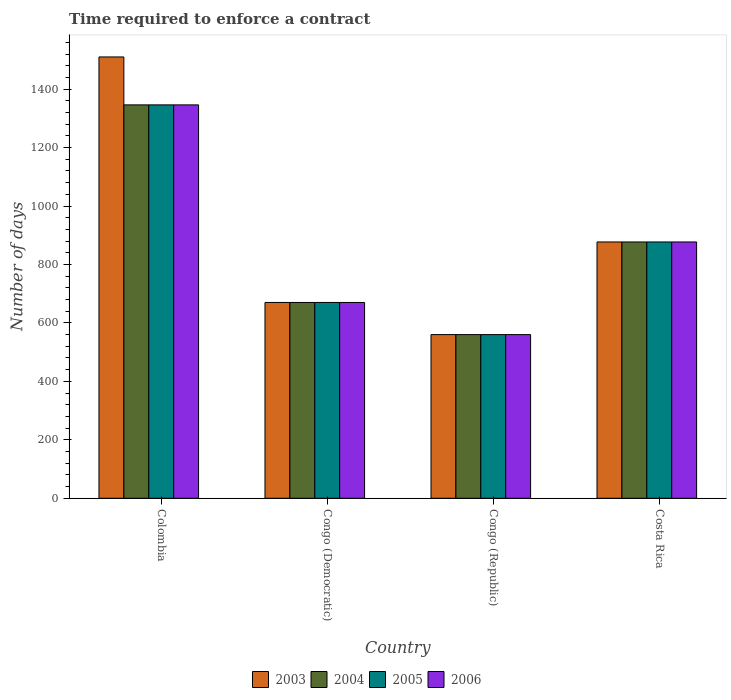How many different coloured bars are there?
Keep it short and to the point. 4. Are the number of bars per tick equal to the number of legend labels?
Your answer should be compact. Yes. How many bars are there on the 4th tick from the right?
Keep it short and to the point. 4. What is the label of the 2nd group of bars from the left?
Provide a short and direct response. Congo (Democratic). What is the number of days required to enforce a contract in 2006 in Congo (Republic)?
Provide a short and direct response. 560. Across all countries, what is the maximum number of days required to enforce a contract in 2003?
Provide a short and direct response. 1510. Across all countries, what is the minimum number of days required to enforce a contract in 2003?
Ensure brevity in your answer.  560. In which country was the number of days required to enforce a contract in 2003 minimum?
Keep it short and to the point. Congo (Republic). What is the total number of days required to enforce a contract in 2005 in the graph?
Give a very brief answer. 3453. What is the difference between the number of days required to enforce a contract in 2005 in Congo (Republic) and that in Costa Rica?
Give a very brief answer. -317. What is the difference between the number of days required to enforce a contract in 2003 in Congo (Democratic) and the number of days required to enforce a contract in 2005 in Congo (Republic)?
Ensure brevity in your answer.  110. What is the average number of days required to enforce a contract in 2005 per country?
Give a very brief answer. 863.25. What is the difference between the number of days required to enforce a contract of/in 2005 and number of days required to enforce a contract of/in 2004 in Congo (Democratic)?
Your answer should be compact. 0. In how many countries, is the number of days required to enforce a contract in 2006 greater than 1400 days?
Your answer should be compact. 0. What is the ratio of the number of days required to enforce a contract in 2006 in Colombia to that in Congo (Democratic)?
Offer a very short reply. 2.01. Is the number of days required to enforce a contract in 2006 in Congo (Democratic) less than that in Congo (Republic)?
Ensure brevity in your answer.  No. What is the difference between the highest and the second highest number of days required to enforce a contract in 2004?
Make the answer very short. 469. What is the difference between the highest and the lowest number of days required to enforce a contract in 2003?
Provide a succinct answer. 950. In how many countries, is the number of days required to enforce a contract in 2003 greater than the average number of days required to enforce a contract in 2003 taken over all countries?
Ensure brevity in your answer.  1. Is the sum of the number of days required to enforce a contract in 2003 in Congo (Republic) and Costa Rica greater than the maximum number of days required to enforce a contract in 2006 across all countries?
Offer a terse response. Yes. What does the 3rd bar from the right in Costa Rica represents?
Ensure brevity in your answer.  2004. Are all the bars in the graph horizontal?
Make the answer very short. No. What is the difference between two consecutive major ticks on the Y-axis?
Keep it short and to the point. 200. Does the graph contain grids?
Provide a short and direct response. No. Where does the legend appear in the graph?
Keep it short and to the point. Bottom center. How many legend labels are there?
Ensure brevity in your answer.  4. What is the title of the graph?
Your answer should be compact. Time required to enforce a contract. What is the label or title of the X-axis?
Make the answer very short. Country. What is the label or title of the Y-axis?
Offer a terse response. Number of days. What is the Number of days in 2003 in Colombia?
Provide a short and direct response. 1510. What is the Number of days of 2004 in Colombia?
Your answer should be very brief. 1346. What is the Number of days in 2005 in Colombia?
Make the answer very short. 1346. What is the Number of days in 2006 in Colombia?
Your answer should be very brief. 1346. What is the Number of days in 2003 in Congo (Democratic)?
Offer a terse response. 670. What is the Number of days in 2004 in Congo (Democratic)?
Ensure brevity in your answer.  670. What is the Number of days of 2005 in Congo (Democratic)?
Your answer should be very brief. 670. What is the Number of days of 2006 in Congo (Democratic)?
Offer a terse response. 670. What is the Number of days of 2003 in Congo (Republic)?
Provide a succinct answer. 560. What is the Number of days of 2004 in Congo (Republic)?
Provide a short and direct response. 560. What is the Number of days of 2005 in Congo (Republic)?
Offer a very short reply. 560. What is the Number of days of 2006 in Congo (Republic)?
Your response must be concise. 560. What is the Number of days of 2003 in Costa Rica?
Your answer should be compact. 877. What is the Number of days in 2004 in Costa Rica?
Offer a very short reply. 877. What is the Number of days of 2005 in Costa Rica?
Your answer should be compact. 877. What is the Number of days of 2006 in Costa Rica?
Your response must be concise. 877. Across all countries, what is the maximum Number of days of 2003?
Offer a very short reply. 1510. Across all countries, what is the maximum Number of days of 2004?
Offer a very short reply. 1346. Across all countries, what is the maximum Number of days of 2005?
Provide a short and direct response. 1346. Across all countries, what is the maximum Number of days in 2006?
Give a very brief answer. 1346. Across all countries, what is the minimum Number of days of 2003?
Ensure brevity in your answer.  560. Across all countries, what is the minimum Number of days in 2004?
Ensure brevity in your answer.  560. Across all countries, what is the minimum Number of days of 2005?
Offer a terse response. 560. Across all countries, what is the minimum Number of days in 2006?
Provide a short and direct response. 560. What is the total Number of days in 2003 in the graph?
Your answer should be very brief. 3617. What is the total Number of days of 2004 in the graph?
Give a very brief answer. 3453. What is the total Number of days of 2005 in the graph?
Ensure brevity in your answer.  3453. What is the total Number of days in 2006 in the graph?
Your response must be concise. 3453. What is the difference between the Number of days in 2003 in Colombia and that in Congo (Democratic)?
Provide a succinct answer. 840. What is the difference between the Number of days of 2004 in Colombia and that in Congo (Democratic)?
Offer a very short reply. 676. What is the difference between the Number of days in 2005 in Colombia and that in Congo (Democratic)?
Give a very brief answer. 676. What is the difference between the Number of days in 2006 in Colombia and that in Congo (Democratic)?
Provide a short and direct response. 676. What is the difference between the Number of days of 2003 in Colombia and that in Congo (Republic)?
Make the answer very short. 950. What is the difference between the Number of days in 2004 in Colombia and that in Congo (Republic)?
Ensure brevity in your answer.  786. What is the difference between the Number of days of 2005 in Colombia and that in Congo (Republic)?
Offer a terse response. 786. What is the difference between the Number of days in 2006 in Colombia and that in Congo (Republic)?
Keep it short and to the point. 786. What is the difference between the Number of days of 2003 in Colombia and that in Costa Rica?
Your response must be concise. 633. What is the difference between the Number of days in 2004 in Colombia and that in Costa Rica?
Ensure brevity in your answer.  469. What is the difference between the Number of days in 2005 in Colombia and that in Costa Rica?
Provide a succinct answer. 469. What is the difference between the Number of days of 2006 in Colombia and that in Costa Rica?
Keep it short and to the point. 469. What is the difference between the Number of days of 2003 in Congo (Democratic) and that in Congo (Republic)?
Offer a terse response. 110. What is the difference between the Number of days of 2004 in Congo (Democratic) and that in Congo (Republic)?
Make the answer very short. 110. What is the difference between the Number of days of 2005 in Congo (Democratic) and that in Congo (Republic)?
Your response must be concise. 110. What is the difference between the Number of days of 2006 in Congo (Democratic) and that in Congo (Republic)?
Offer a terse response. 110. What is the difference between the Number of days in 2003 in Congo (Democratic) and that in Costa Rica?
Make the answer very short. -207. What is the difference between the Number of days of 2004 in Congo (Democratic) and that in Costa Rica?
Make the answer very short. -207. What is the difference between the Number of days of 2005 in Congo (Democratic) and that in Costa Rica?
Provide a succinct answer. -207. What is the difference between the Number of days in 2006 in Congo (Democratic) and that in Costa Rica?
Offer a very short reply. -207. What is the difference between the Number of days in 2003 in Congo (Republic) and that in Costa Rica?
Provide a succinct answer. -317. What is the difference between the Number of days in 2004 in Congo (Republic) and that in Costa Rica?
Offer a very short reply. -317. What is the difference between the Number of days in 2005 in Congo (Republic) and that in Costa Rica?
Give a very brief answer. -317. What is the difference between the Number of days of 2006 in Congo (Republic) and that in Costa Rica?
Offer a terse response. -317. What is the difference between the Number of days in 2003 in Colombia and the Number of days in 2004 in Congo (Democratic)?
Your answer should be very brief. 840. What is the difference between the Number of days in 2003 in Colombia and the Number of days in 2005 in Congo (Democratic)?
Provide a short and direct response. 840. What is the difference between the Number of days in 2003 in Colombia and the Number of days in 2006 in Congo (Democratic)?
Your answer should be compact. 840. What is the difference between the Number of days of 2004 in Colombia and the Number of days of 2005 in Congo (Democratic)?
Give a very brief answer. 676. What is the difference between the Number of days of 2004 in Colombia and the Number of days of 2006 in Congo (Democratic)?
Make the answer very short. 676. What is the difference between the Number of days in 2005 in Colombia and the Number of days in 2006 in Congo (Democratic)?
Keep it short and to the point. 676. What is the difference between the Number of days in 2003 in Colombia and the Number of days in 2004 in Congo (Republic)?
Give a very brief answer. 950. What is the difference between the Number of days in 2003 in Colombia and the Number of days in 2005 in Congo (Republic)?
Offer a terse response. 950. What is the difference between the Number of days of 2003 in Colombia and the Number of days of 2006 in Congo (Republic)?
Give a very brief answer. 950. What is the difference between the Number of days of 2004 in Colombia and the Number of days of 2005 in Congo (Republic)?
Your response must be concise. 786. What is the difference between the Number of days in 2004 in Colombia and the Number of days in 2006 in Congo (Republic)?
Your answer should be very brief. 786. What is the difference between the Number of days of 2005 in Colombia and the Number of days of 2006 in Congo (Republic)?
Make the answer very short. 786. What is the difference between the Number of days of 2003 in Colombia and the Number of days of 2004 in Costa Rica?
Give a very brief answer. 633. What is the difference between the Number of days in 2003 in Colombia and the Number of days in 2005 in Costa Rica?
Keep it short and to the point. 633. What is the difference between the Number of days in 2003 in Colombia and the Number of days in 2006 in Costa Rica?
Make the answer very short. 633. What is the difference between the Number of days in 2004 in Colombia and the Number of days in 2005 in Costa Rica?
Your response must be concise. 469. What is the difference between the Number of days in 2004 in Colombia and the Number of days in 2006 in Costa Rica?
Provide a succinct answer. 469. What is the difference between the Number of days of 2005 in Colombia and the Number of days of 2006 in Costa Rica?
Your answer should be very brief. 469. What is the difference between the Number of days in 2003 in Congo (Democratic) and the Number of days in 2004 in Congo (Republic)?
Provide a succinct answer. 110. What is the difference between the Number of days of 2003 in Congo (Democratic) and the Number of days of 2005 in Congo (Republic)?
Give a very brief answer. 110. What is the difference between the Number of days in 2003 in Congo (Democratic) and the Number of days in 2006 in Congo (Republic)?
Your response must be concise. 110. What is the difference between the Number of days in 2004 in Congo (Democratic) and the Number of days in 2005 in Congo (Republic)?
Offer a terse response. 110. What is the difference between the Number of days of 2004 in Congo (Democratic) and the Number of days of 2006 in Congo (Republic)?
Ensure brevity in your answer.  110. What is the difference between the Number of days in 2005 in Congo (Democratic) and the Number of days in 2006 in Congo (Republic)?
Provide a succinct answer. 110. What is the difference between the Number of days in 2003 in Congo (Democratic) and the Number of days in 2004 in Costa Rica?
Offer a terse response. -207. What is the difference between the Number of days of 2003 in Congo (Democratic) and the Number of days of 2005 in Costa Rica?
Your response must be concise. -207. What is the difference between the Number of days of 2003 in Congo (Democratic) and the Number of days of 2006 in Costa Rica?
Give a very brief answer. -207. What is the difference between the Number of days in 2004 in Congo (Democratic) and the Number of days in 2005 in Costa Rica?
Ensure brevity in your answer.  -207. What is the difference between the Number of days of 2004 in Congo (Democratic) and the Number of days of 2006 in Costa Rica?
Your response must be concise. -207. What is the difference between the Number of days of 2005 in Congo (Democratic) and the Number of days of 2006 in Costa Rica?
Make the answer very short. -207. What is the difference between the Number of days of 2003 in Congo (Republic) and the Number of days of 2004 in Costa Rica?
Your answer should be compact. -317. What is the difference between the Number of days of 2003 in Congo (Republic) and the Number of days of 2005 in Costa Rica?
Ensure brevity in your answer.  -317. What is the difference between the Number of days of 2003 in Congo (Republic) and the Number of days of 2006 in Costa Rica?
Your response must be concise. -317. What is the difference between the Number of days of 2004 in Congo (Republic) and the Number of days of 2005 in Costa Rica?
Your answer should be very brief. -317. What is the difference between the Number of days in 2004 in Congo (Republic) and the Number of days in 2006 in Costa Rica?
Give a very brief answer. -317. What is the difference between the Number of days of 2005 in Congo (Republic) and the Number of days of 2006 in Costa Rica?
Provide a short and direct response. -317. What is the average Number of days in 2003 per country?
Offer a terse response. 904.25. What is the average Number of days of 2004 per country?
Provide a short and direct response. 863.25. What is the average Number of days of 2005 per country?
Offer a terse response. 863.25. What is the average Number of days of 2006 per country?
Provide a succinct answer. 863.25. What is the difference between the Number of days in 2003 and Number of days in 2004 in Colombia?
Your answer should be very brief. 164. What is the difference between the Number of days of 2003 and Number of days of 2005 in Colombia?
Your answer should be compact. 164. What is the difference between the Number of days in 2003 and Number of days in 2006 in Colombia?
Give a very brief answer. 164. What is the difference between the Number of days in 2005 and Number of days in 2006 in Colombia?
Make the answer very short. 0. What is the difference between the Number of days in 2003 and Number of days in 2006 in Congo (Democratic)?
Offer a very short reply. 0. What is the difference between the Number of days of 2004 and Number of days of 2006 in Congo (Democratic)?
Offer a terse response. 0. What is the difference between the Number of days in 2003 and Number of days in 2005 in Congo (Republic)?
Give a very brief answer. 0. What is the difference between the Number of days of 2003 and Number of days of 2004 in Costa Rica?
Provide a succinct answer. 0. What is the difference between the Number of days of 2003 and Number of days of 2005 in Costa Rica?
Your answer should be compact. 0. What is the difference between the Number of days in 2004 and Number of days in 2006 in Costa Rica?
Give a very brief answer. 0. What is the ratio of the Number of days of 2003 in Colombia to that in Congo (Democratic)?
Make the answer very short. 2.25. What is the ratio of the Number of days in 2004 in Colombia to that in Congo (Democratic)?
Give a very brief answer. 2.01. What is the ratio of the Number of days of 2005 in Colombia to that in Congo (Democratic)?
Offer a terse response. 2.01. What is the ratio of the Number of days in 2006 in Colombia to that in Congo (Democratic)?
Provide a short and direct response. 2.01. What is the ratio of the Number of days in 2003 in Colombia to that in Congo (Republic)?
Offer a terse response. 2.7. What is the ratio of the Number of days in 2004 in Colombia to that in Congo (Republic)?
Your answer should be very brief. 2.4. What is the ratio of the Number of days of 2005 in Colombia to that in Congo (Republic)?
Make the answer very short. 2.4. What is the ratio of the Number of days of 2006 in Colombia to that in Congo (Republic)?
Your answer should be compact. 2.4. What is the ratio of the Number of days of 2003 in Colombia to that in Costa Rica?
Provide a succinct answer. 1.72. What is the ratio of the Number of days in 2004 in Colombia to that in Costa Rica?
Offer a very short reply. 1.53. What is the ratio of the Number of days of 2005 in Colombia to that in Costa Rica?
Ensure brevity in your answer.  1.53. What is the ratio of the Number of days in 2006 in Colombia to that in Costa Rica?
Ensure brevity in your answer.  1.53. What is the ratio of the Number of days of 2003 in Congo (Democratic) to that in Congo (Republic)?
Make the answer very short. 1.2. What is the ratio of the Number of days of 2004 in Congo (Democratic) to that in Congo (Republic)?
Ensure brevity in your answer.  1.2. What is the ratio of the Number of days in 2005 in Congo (Democratic) to that in Congo (Republic)?
Keep it short and to the point. 1.2. What is the ratio of the Number of days of 2006 in Congo (Democratic) to that in Congo (Republic)?
Your answer should be very brief. 1.2. What is the ratio of the Number of days in 2003 in Congo (Democratic) to that in Costa Rica?
Ensure brevity in your answer.  0.76. What is the ratio of the Number of days in 2004 in Congo (Democratic) to that in Costa Rica?
Provide a succinct answer. 0.76. What is the ratio of the Number of days in 2005 in Congo (Democratic) to that in Costa Rica?
Offer a terse response. 0.76. What is the ratio of the Number of days in 2006 in Congo (Democratic) to that in Costa Rica?
Give a very brief answer. 0.76. What is the ratio of the Number of days of 2003 in Congo (Republic) to that in Costa Rica?
Your answer should be compact. 0.64. What is the ratio of the Number of days of 2004 in Congo (Republic) to that in Costa Rica?
Your response must be concise. 0.64. What is the ratio of the Number of days in 2005 in Congo (Republic) to that in Costa Rica?
Your answer should be compact. 0.64. What is the ratio of the Number of days in 2006 in Congo (Republic) to that in Costa Rica?
Keep it short and to the point. 0.64. What is the difference between the highest and the second highest Number of days in 2003?
Your answer should be very brief. 633. What is the difference between the highest and the second highest Number of days of 2004?
Your response must be concise. 469. What is the difference between the highest and the second highest Number of days in 2005?
Give a very brief answer. 469. What is the difference between the highest and the second highest Number of days in 2006?
Provide a short and direct response. 469. What is the difference between the highest and the lowest Number of days of 2003?
Your answer should be compact. 950. What is the difference between the highest and the lowest Number of days of 2004?
Your response must be concise. 786. What is the difference between the highest and the lowest Number of days of 2005?
Give a very brief answer. 786. What is the difference between the highest and the lowest Number of days of 2006?
Make the answer very short. 786. 